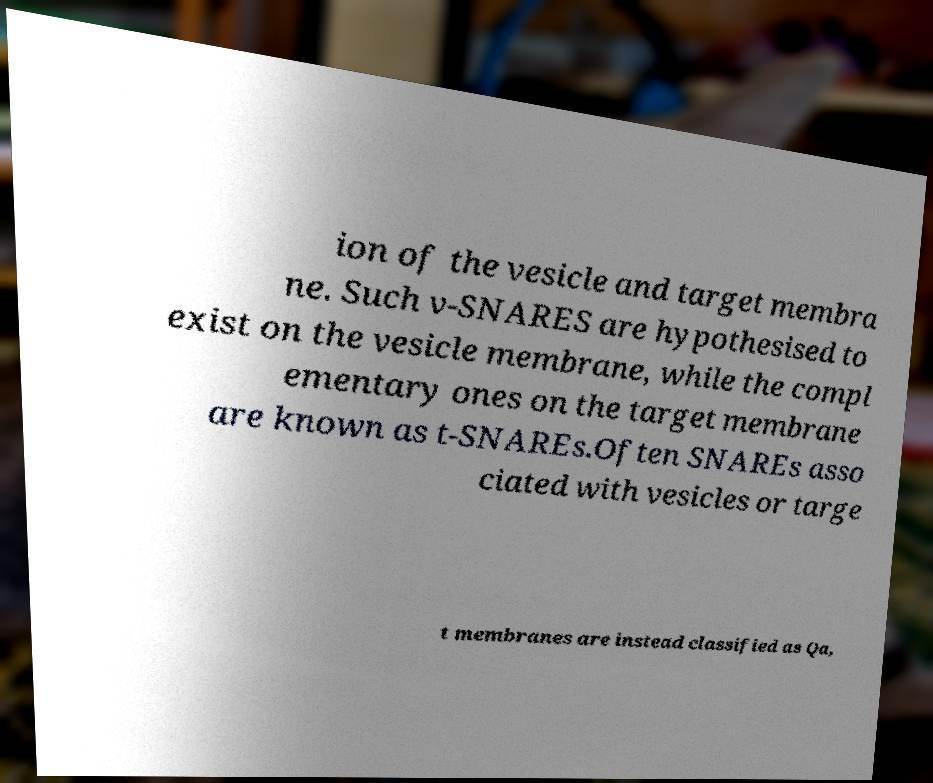I need the written content from this picture converted into text. Can you do that? ion of the vesicle and target membra ne. Such v-SNARES are hypothesised to exist on the vesicle membrane, while the compl ementary ones on the target membrane are known as t-SNAREs.Often SNAREs asso ciated with vesicles or targe t membranes are instead classified as Qa, 